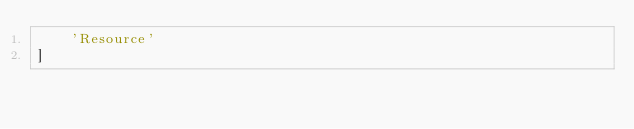Convert code to text. <code><loc_0><loc_0><loc_500><loc_500><_Python_>    'Resource'
]
</code> 